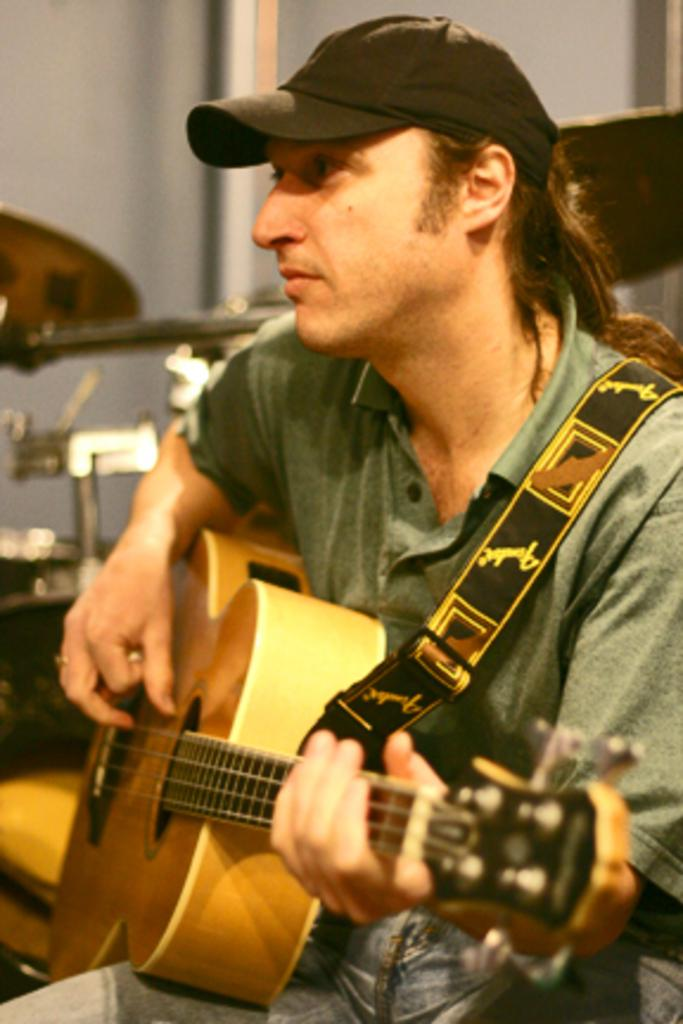Who is the main subject in the image? There is a man in the image. What is the man doing in the image? The man is sitting on a chair and playing a guitar. What type of headwear is the man wearing? The man is wearing a cap. What level of difficulty is the man attempting to achieve while playing the guitar in the image? The image does not provide information about the level of difficulty the man is attempting to achieve while playing the guitar. 